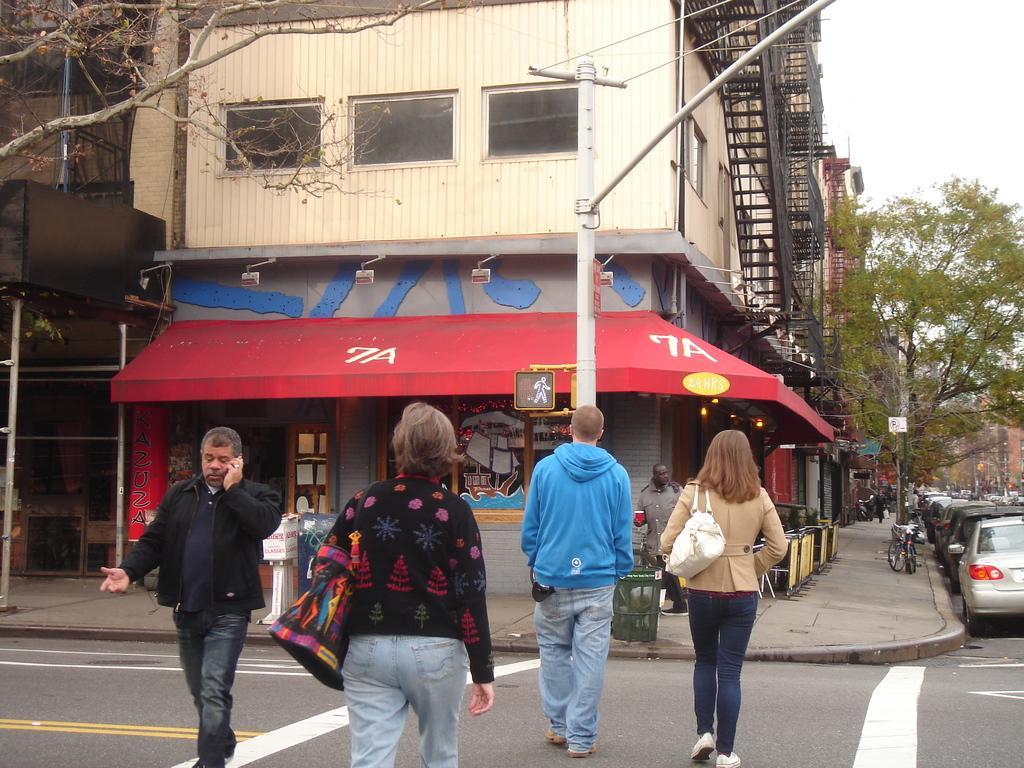Can you describe this image briefly? In this picture there are buildings and trees. In the foreground there are group of people walking on the road and there are dustbins and there is a bicycle and there are poles on the footpath. On the right side of the image there are vehicles on the road. At the top there is sky. At the bottom there is a road. 